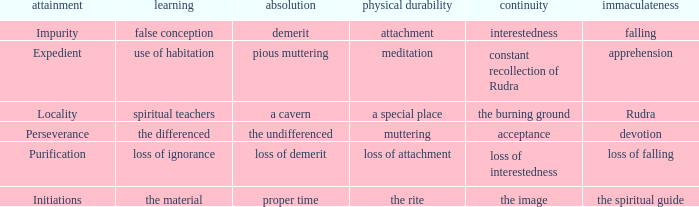 what's the permanence of the body where purity is rudra A special place. 